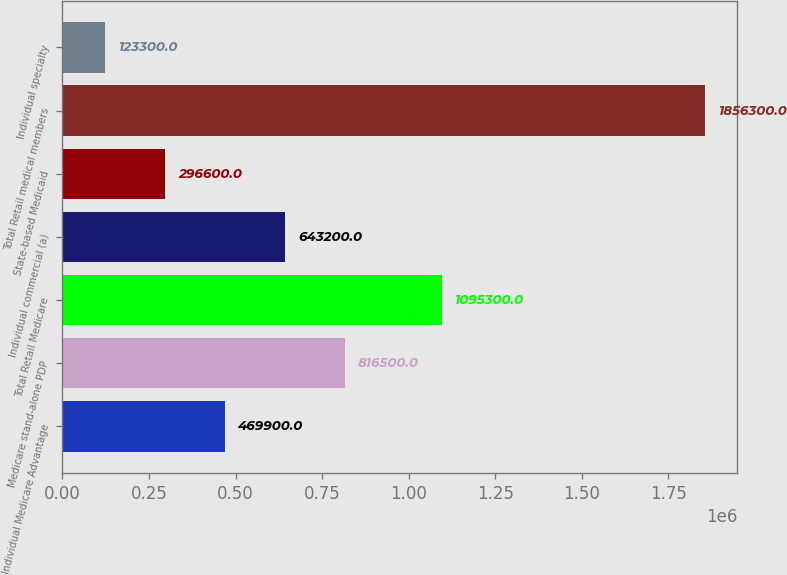Convert chart. <chart><loc_0><loc_0><loc_500><loc_500><bar_chart><fcel>Individual Medicare Advantage<fcel>Medicare stand-alone PDP<fcel>Total Retail Medicare<fcel>Individual commercial (a)<fcel>State-based Medicaid<fcel>Total Retail medical members<fcel>Individual specialty<nl><fcel>469900<fcel>816500<fcel>1.0953e+06<fcel>643200<fcel>296600<fcel>1.8563e+06<fcel>123300<nl></chart> 